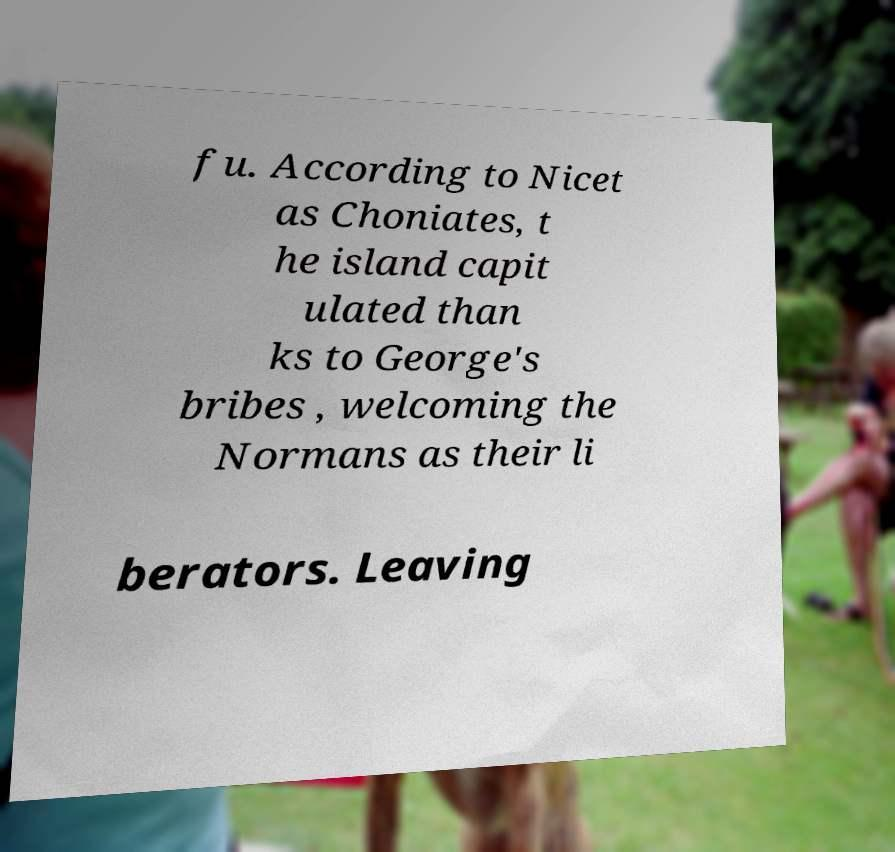Could you extract and type out the text from this image? fu. According to Nicet as Choniates, t he island capit ulated than ks to George's bribes , welcoming the Normans as their li berators. Leaving 